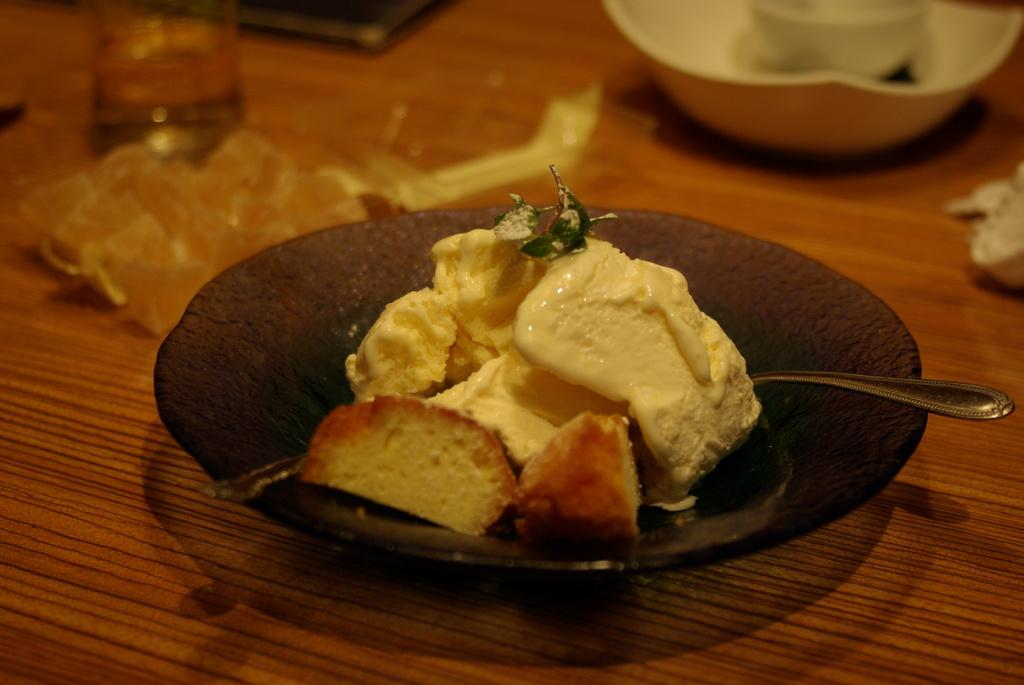What is the main food item visible in the image? There is a food item in a plate in the image. What is the liquid-filled container in the image? There is a glass with liquid in it in the image. What can be found on the table in the image? There are objects on the table in the image, including a bowl. Can you describe the bowl on the table? There is a bowl on the table in the image. What type of pancake is being observed in the image? There is no pancake present in the image. What kind of powder is visible on the table in the image? There is no powder visible on the table in the image. 